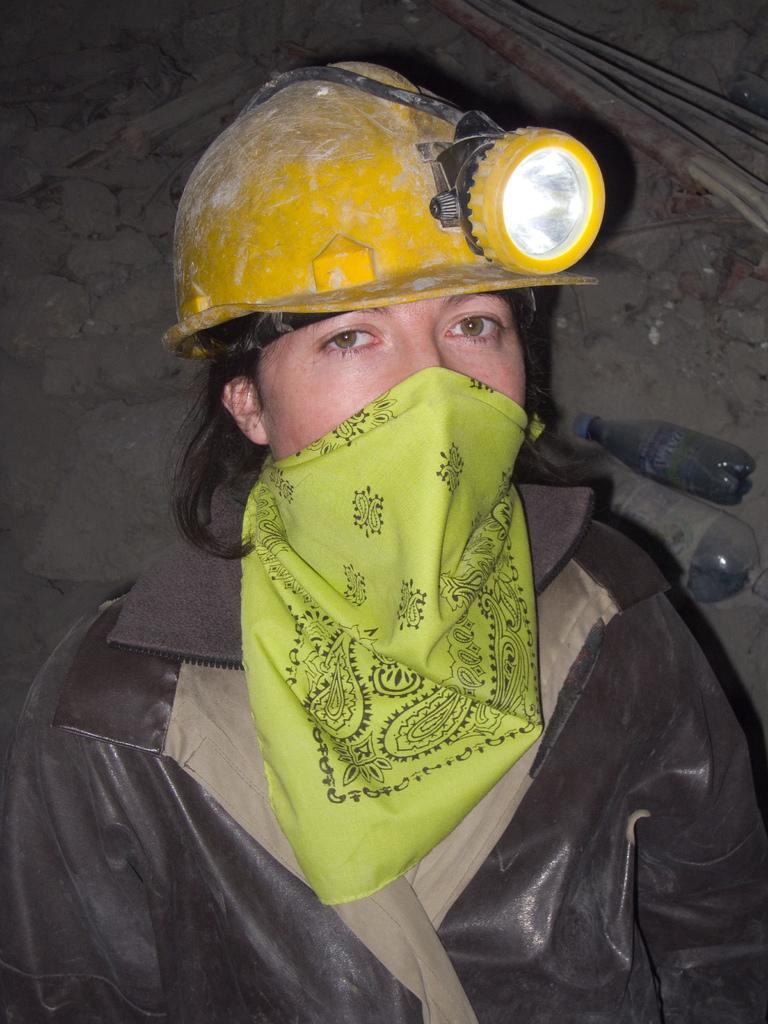Can you describe this image briefly? In this image we can see a person and the person is wearing a scarf and a safety helmet. Behind the person we can see a bottle and stones. In the top right, we can see the wires. 